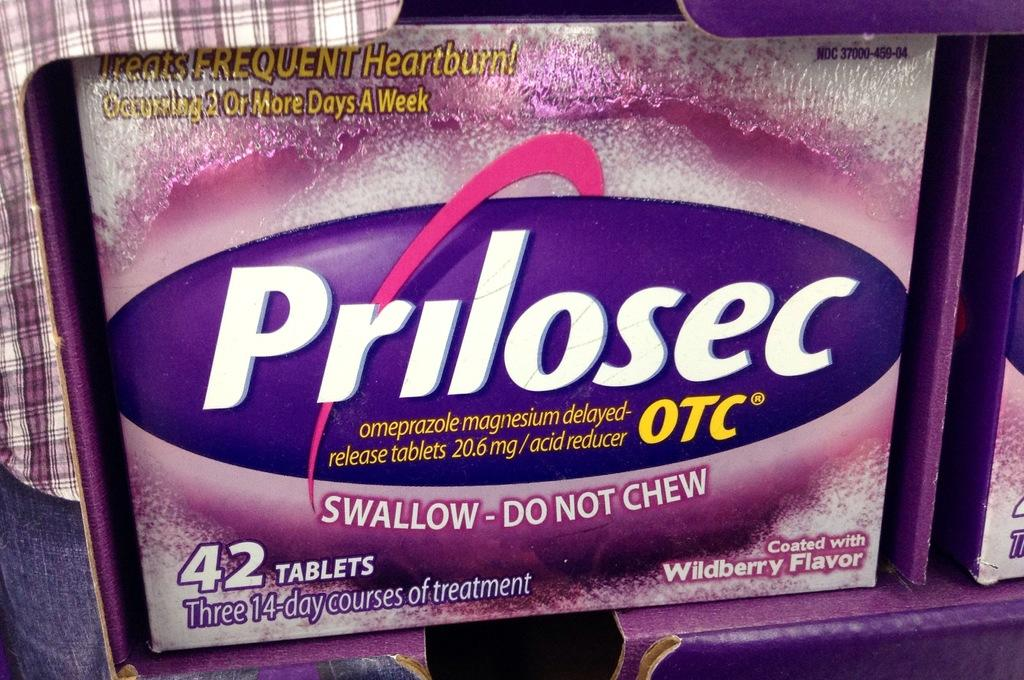What is the main object in the image? There is a box in the image. What can be found on the surface of the box? The box has text and numbers written on it. What color is present among the objects in the image? There are objects in the image that are pink in color. What type of trouble is the horse causing in the image? There is no horse present in the image, so it is not possible to determine any trouble caused by a horse. 